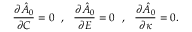<formula> <loc_0><loc_0><loc_500><loc_500>\frac { \partial \hat { A } _ { 0 } } { \partial C } = 0 , \frac { \partial \hat { A } _ { 0 } } { \partial E } = 0 , \frac { \partial \hat { A } _ { 0 } } { \partial \kappa } = 0 .</formula> 